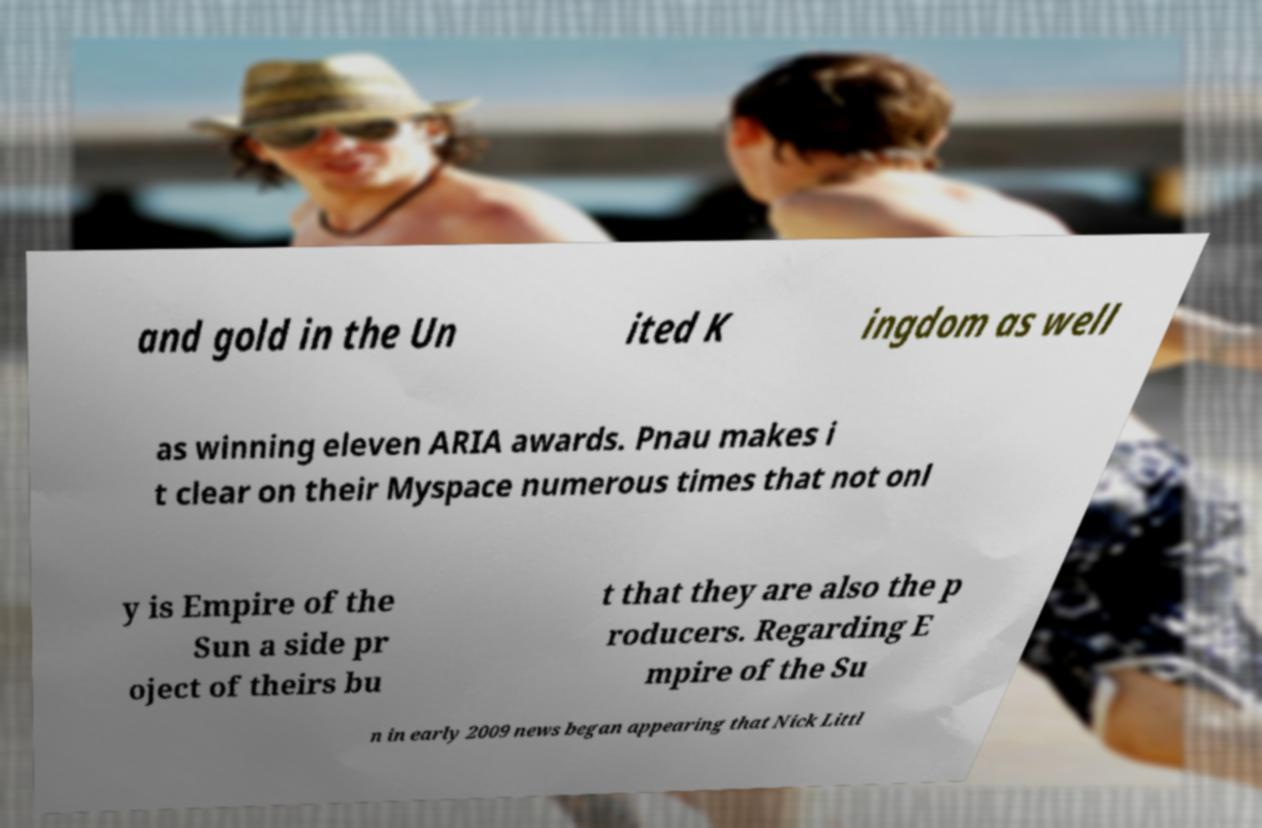Please identify and transcribe the text found in this image. and gold in the Un ited K ingdom as well as winning eleven ARIA awards. Pnau makes i t clear on their Myspace numerous times that not onl y is Empire of the Sun a side pr oject of theirs bu t that they are also the p roducers. Regarding E mpire of the Su n in early 2009 news began appearing that Nick Littl 